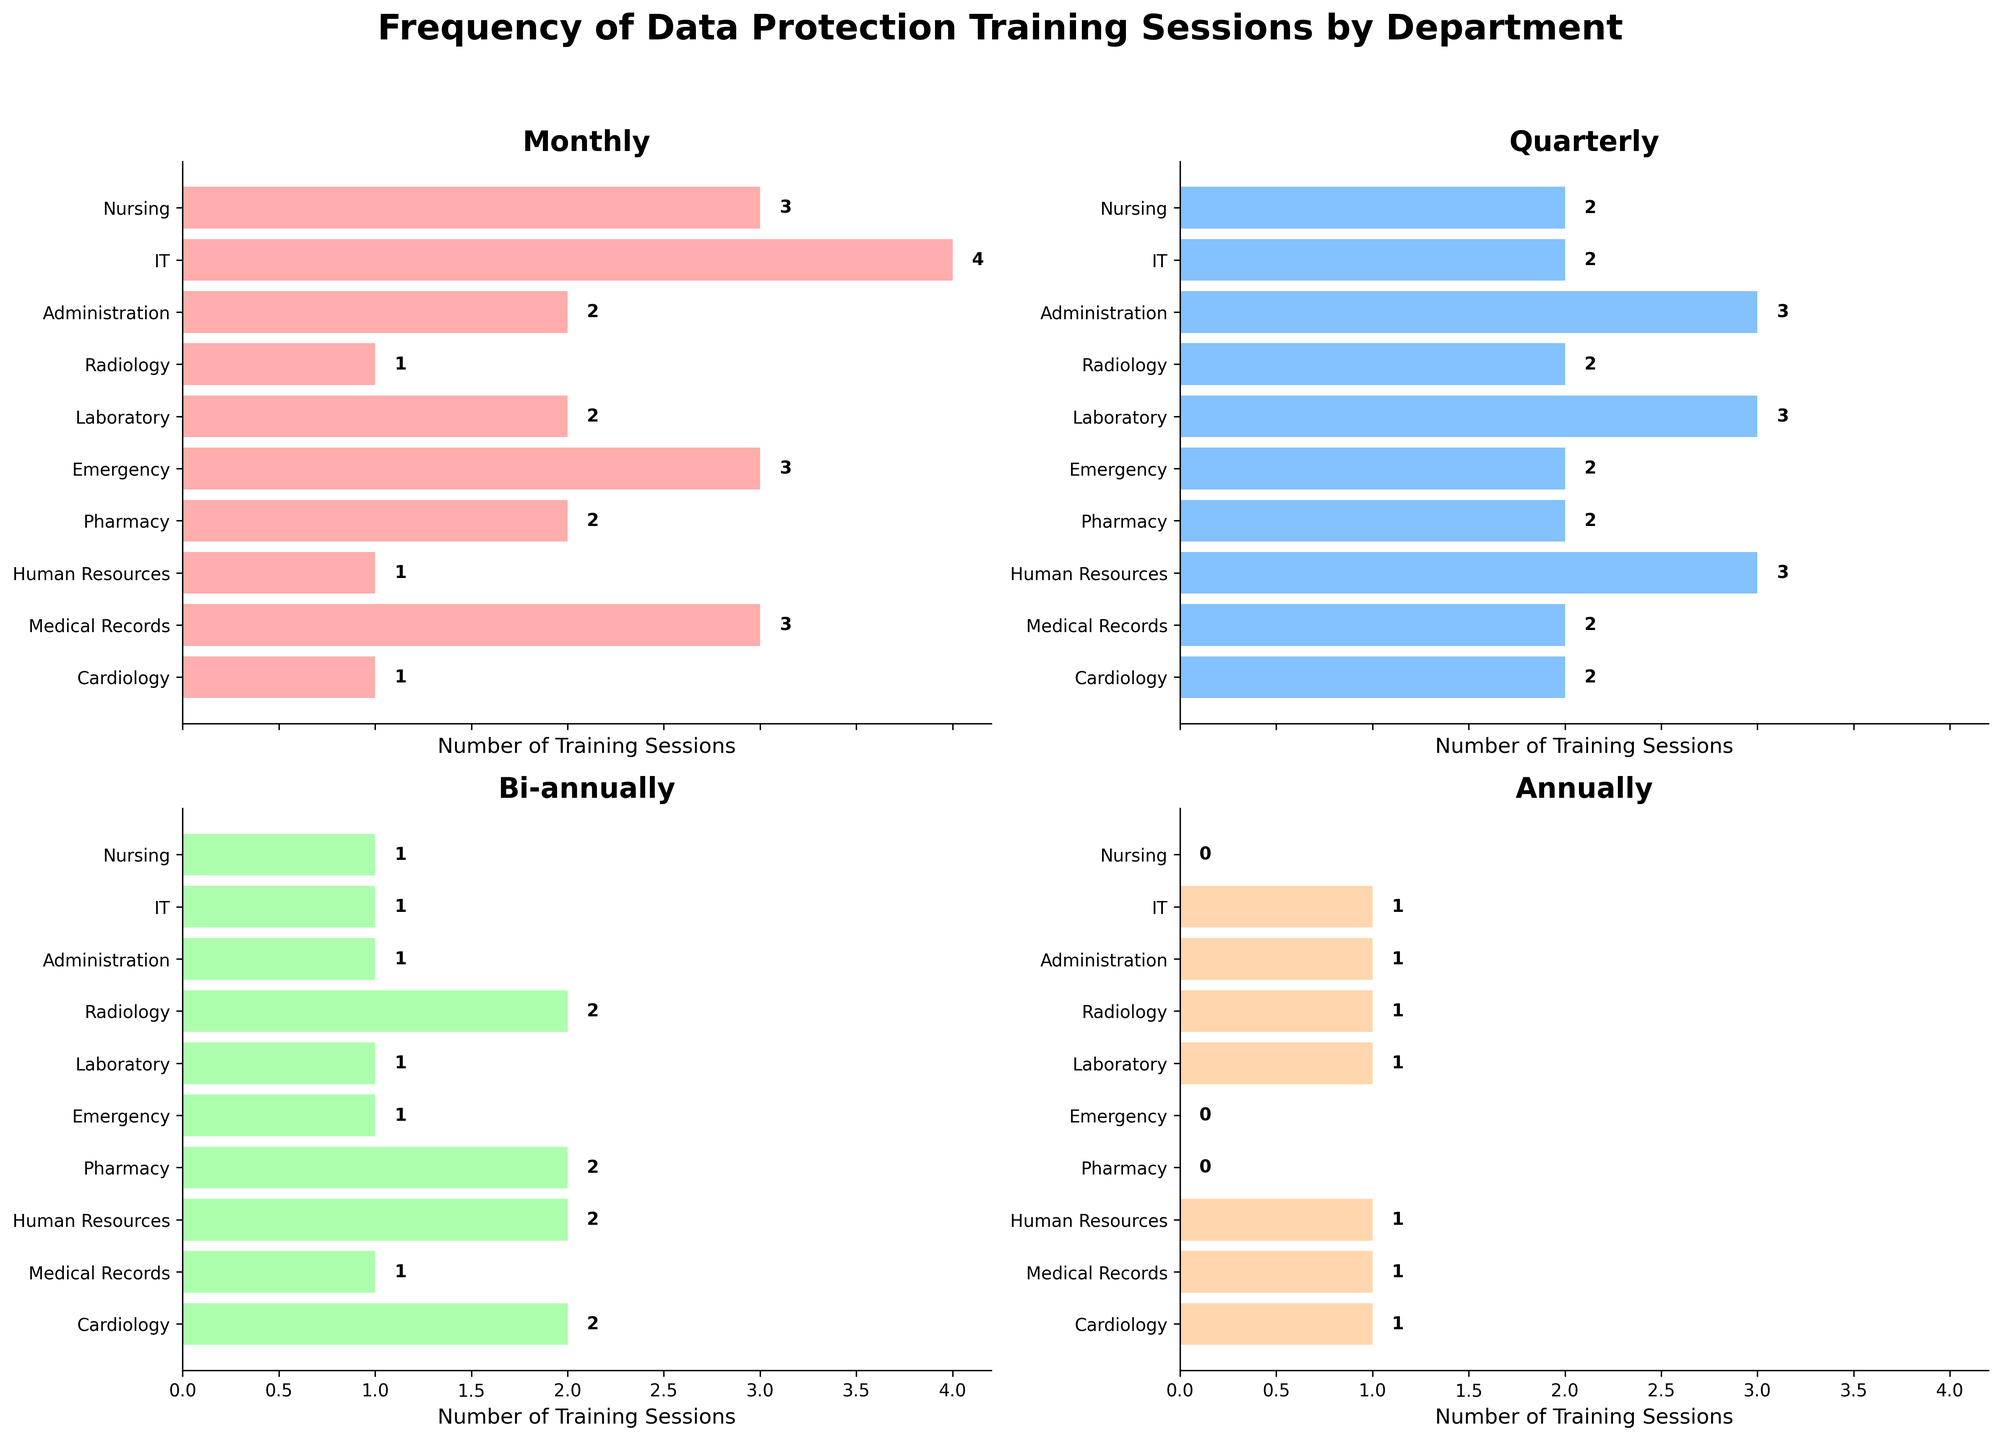What is the title of the figure? The title is displayed at the top of the figure.
Answer: Frequency of Data Protection Training Sessions by Department Which department conducts the most monthly training sessions? By looking at the "Monthly" bar chart, identify which bar is the longest.
Answer: IT How many training sessions does the Radiology department conduct bi-annually? Check the "Bi-annually" bar chart and locate the Radiology department's bar.
Answer: 2 What department has the least number of quarterly training sessions? By examining the "Quarterly" subplot, find the shortest bar.
Answer: Nursing and Pharmacy (tie) What is the difference between the number of quarterly and annually training sessions in the IT department? Subtract the number of annually training sessions from the number of quarterly sessions for the IT department.
Answer: 1 What is the average number of monthly training sessions across all departments? Sum the values from the "Monthly" column and divide by the number of departments (10).
Answer: 2.2 Which department has equal numbers of bi-annual and annual training sessions? Look for a department with equal length bars in the "Bi-annually" and "Annually" charts.
Answer: Radiology Compare the total number of annual training sessions in the Nursing and Laboratory departments. Which is greater? Add the values from the "Annually" column for both departments and compare.
Answer: Laboratory Which frequency category has the highest number of total training sessions across all departments? Sum the values for each frequency category and find the highest total.
Answer: Monthly How many more monthly training sessions does the IT department conduct compared to the Human Resources department? Subtract the number of monthly sessions in Human Resources from IT.
Answer: 3 